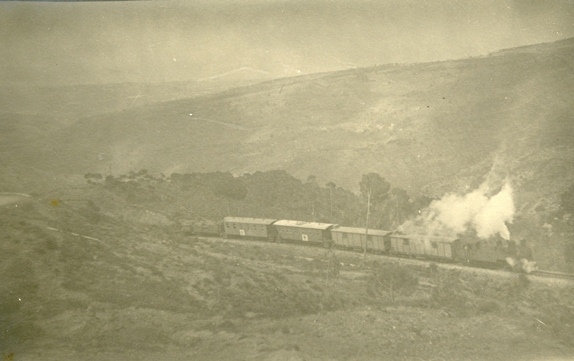<image>Which direction is the training in this picture going? I am not sure about the direction the train is going. However, it might be going to the right. Which direction is the training in this picture going? I am not sure which direction the training in this picture is going. It can be seen going to the right or forward. 